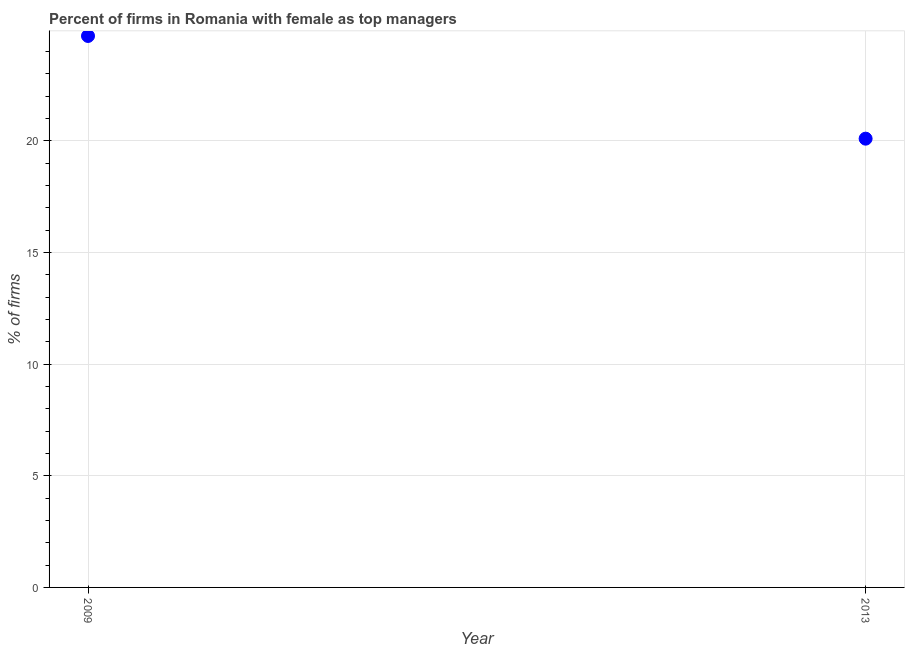What is the percentage of firms with female as top manager in 2009?
Your answer should be very brief. 24.7. Across all years, what is the maximum percentage of firms with female as top manager?
Provide a succinct answer. 24.7. Across all years, what is the minimum percentage of firms with female as top manager?
Provide a succinct answer. 20.1. In which year was the percentage of firms with female as top manager minimum?
Keep it short and to the point. 2013. What is the sum of the percentage of firms with female as top manager?
Your answer should be compact. 44.8. What is the difference between the percentage of firms with female as top manager in 2009 and 2013?
Provide a succinct answer. 4.6. What is the average percentage of firms with female as top manager per year?
Your answer should be compact. 22.4. What is the median percentage of firms with female as top manager?
Your answer should be very brief. 22.4. What is the ratio of the percentage of firms with female as top manager in 2009 to that in 2013?
Your answer should be very brief. 1.23. Does the percentage of firms with female as top manager monotonically increase over the years?
Your answer should be very brief. No. How many dotlines are there?
Keep it short and to the point. 1. How many years are there in the graph?
Keep it short and to the point. 2. Does the graph contain any zero values?
Offer a very short reply. No. Does the graph contain grids?
Your answer should be compact. Yes. What is the title of the graph?
Your answer should be very brief. Percent of firms in Romania with female as top managers. What is the label or title of the X-axis?
Offer a very short reply. Year. What is the label or title of the Y-axis?
Make the answer very short. % of firms. What is the % of firms in 2009?
Ensure brevity in your answer.  24.7. What is the % of firms in 2013?
Keep it short and to the point. 20.1. What is the ratio of the % of firms in 2009 to that in 2013?
Make the answer very short. 1.23. 